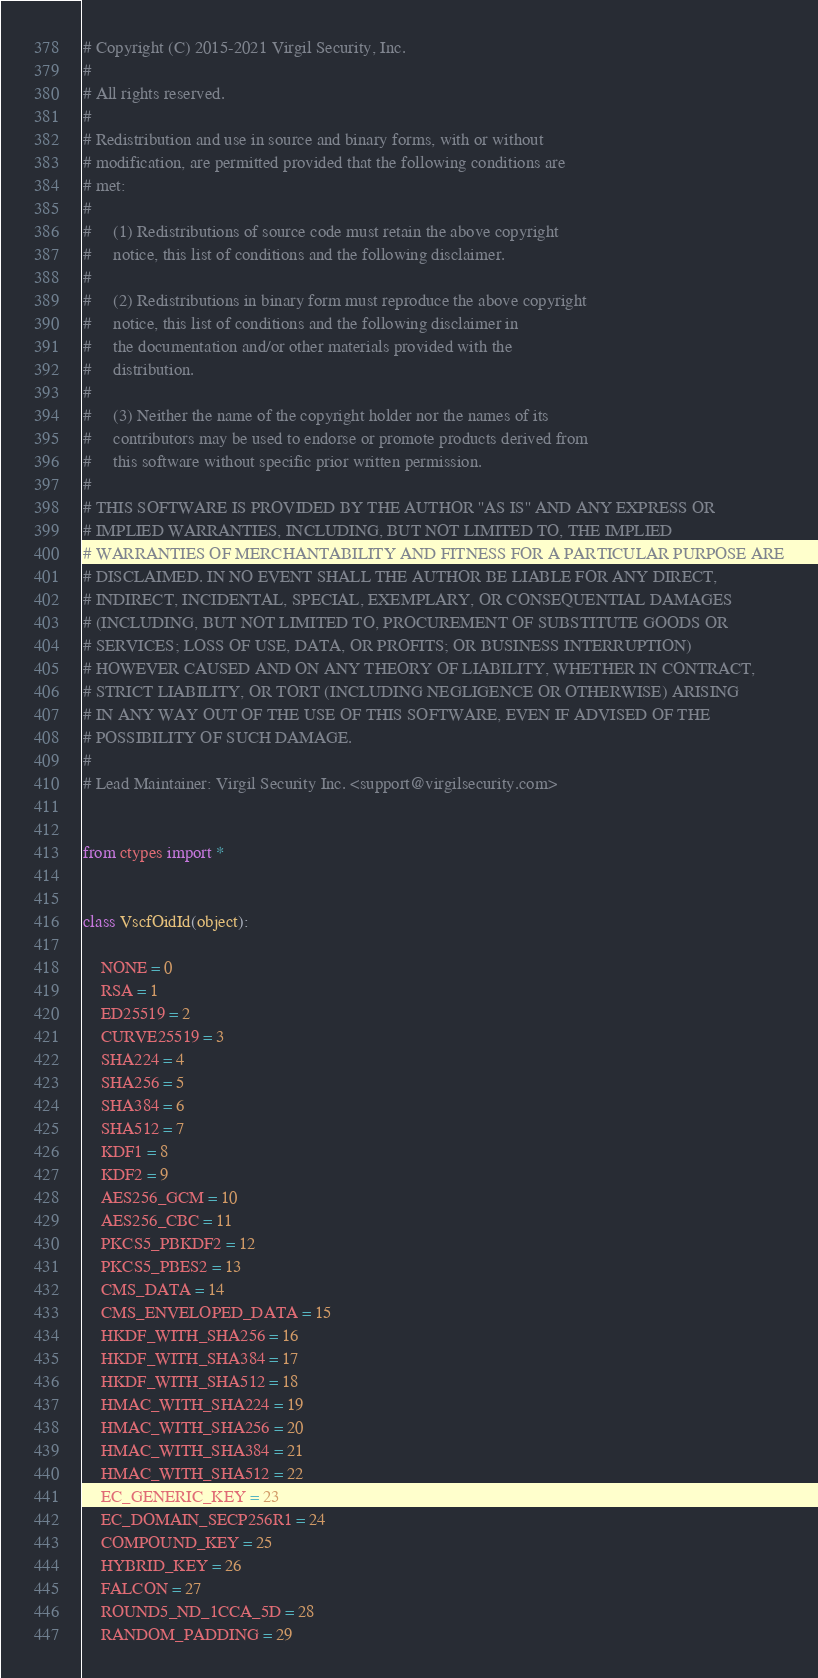Convert code to text. <code><loc_0><loc_0><loc_500><loc_500><_Python_># Copyright (C) 2015-2021 Virgil Security, Inc.
#
# All rights reserved.
#
# Redistribution and use in source and binary forms, with or without
# modification, are permitted provided that the following conditions are
# met:
#
#     (1) Redistributions of source code must retain the above copyright
#     notice, this list of conditions and the following disclaimer.
#
#     (2) Redistributions in binary form must reproduce the above copyright
#     notice, this list of conditions and the following disclaimer in
#     the documentation and/or other materials provided with the
#     distribution.
#
#     (3) Neither the name of the copyright holder nor the names of its
#     contributors may be used to endorse or promote products derived from
#     this software without specific prior written permission.
#
# THIS SOFTWARE IS PROVIDED BY THE AUTHOR ''AS IS'' AND ANY EXPRESS OR
# IMPLIED WARRANTIES, INCLUDING, BUT NOT LIMITED TO, THE IMPLIED
# WARRANTIES OF MERCHANTABILITY AND FITNESS FOR A PARTICULAR PURPOSE ARE
# DISCLAIMED. IN NO EVENT SHALL THE AUTHOR BE LIABLE FOR ANY DIRECT,
# INDIRECT, INCIDENTAL, SPECIAL, EXEMPLARY, OR CONSEQUENTIAL DAMAGES
# (INCLUDING, BUT NOT LIMITED TO, PROCUREMENT OF SUBSTITUTE GOODS OR
# SERVICES; LOSS OF USE, DATA, OR PROFITS; OR BUSINESS INTERRUPTION)
# HOWEVER CAUSED AND ON ANY THEORY OF LIABILITY, WHETHER IN CONTRACT,
# STRICT LIABILITY, OR TORT (INCLUDING NEGLIGENCE OR OTHERWISE) ARISING
# IN ANY WAY OUT OF THE USE OF THIS SOFTWARE, EVEN IF ADVISED OF THE
# POSSIBILITY OF SUCH DAMAGE.
#
# Lead Maintainer: Virgil Security Inc. <support@virgilsecurity.com>


from ctypes import *


class VscfOidId(object):

    NONE = 0
    RSA = 1
    ED25519 = 2
    CURVE25519 = 3
    SHA224 = 4
    SHA256 = 5
    SHA384 = 6
    SHA512 = 7
    KDF1 = 8
    KDF2 = 9
    AES256_GCM = 10
    AES256_CBC = 11
    PKCS5_PBKDF2 = 12
    PKCS5_PBES2 = 13
    CMS_DATA = 14
    CMS_ENVELOPED_DATA = 15
    HKDF_WITH_SHA256 = 16
    HKDF_WITH_SHA384 = 17
    HKDF_WITH_SHA512 = 18
    HMAC_WITH_SHA224 = 19
    HMAC_WITH_SHA256 = 20
    HMAC_WITH_SHA384 = 21
    HMAC_WITH_SHA512 = 22
    EC_GENERIC_KEY = 23
    EC_DOMAIN_SECP256R1 = 24
    COMPOUND_KEY = 25
    HYBRID_KEY = 26
    FALCON = 27
    ROUND5_ND_1CCA_5D = 28
    RANDOM_PADDING = 29
</code> 